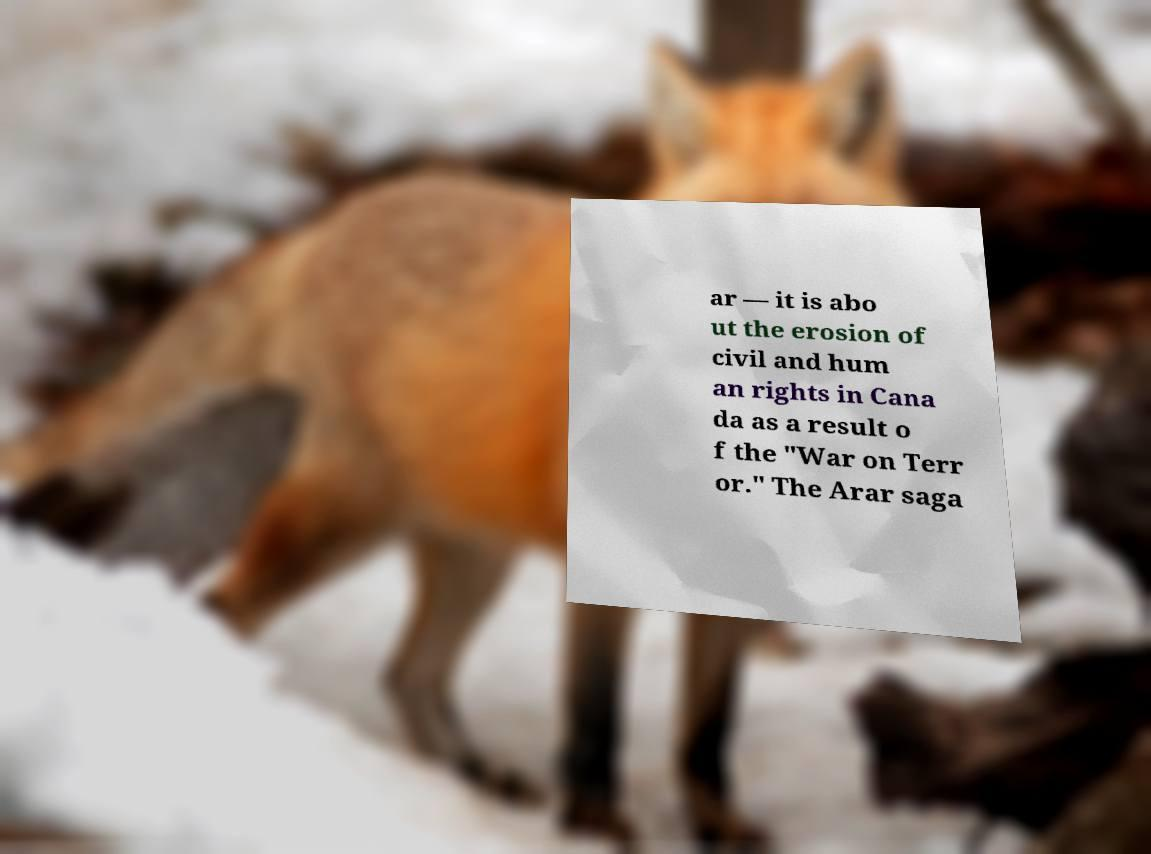Could you assist in decoding the text presented in this image and type it out clearly? ar — it is abo ut the erosion of civil and hum an rights in Cana da as a result o f the "War on Terr or." The Arar saga 